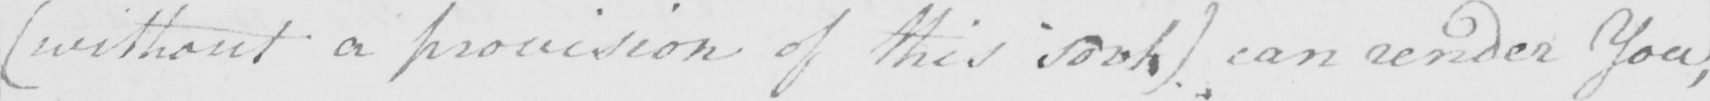Please provide the text content of this handwritten line. ( without a provision of this sort )  can render You , 